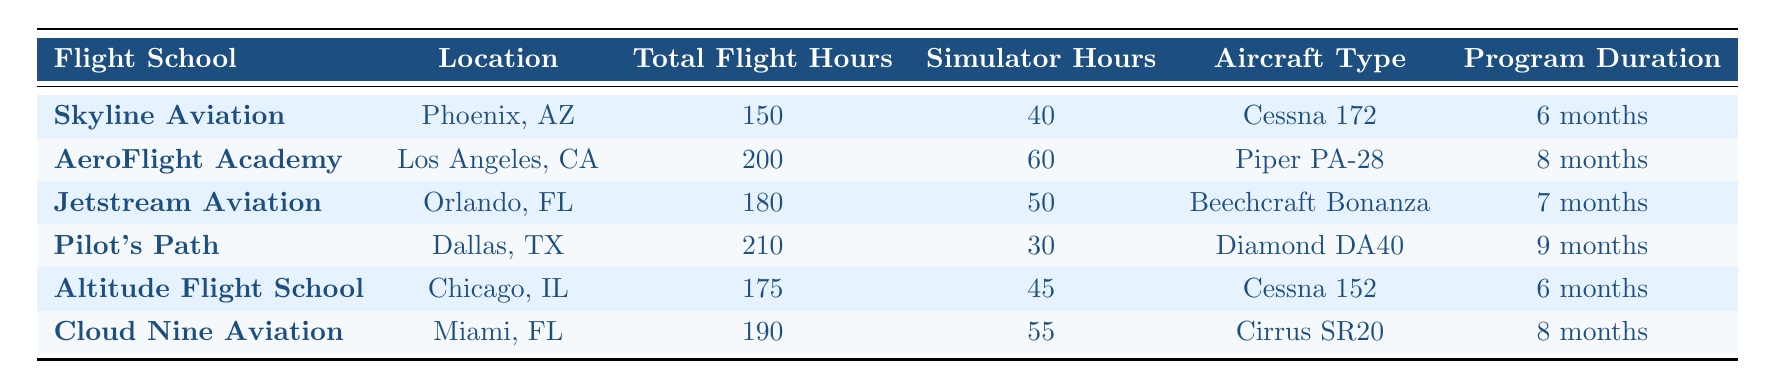What is the total flight hours for Pilot's Path? According to the table, Pilot's Path has a total of 210 flight hours listed in the "Total Flight Hours" column.
Answer: 210 Which flight school is located in Miami, FL? The table shows that Cloud Nine Aviation is the flight school located in Miami, FL, according to the "Location" column.
Answer: Cloud Nine Aviation What is the average total flight hours across all schools? To find the average, add all total flight hours: 150 + 200 + 180 + 210 + 175 + 190 = 1105. Then, divide by the number of schools (6), which gives 1105 / 6 = 184.17.
Answer: 184.17 True or False: Altitude Flight School has more simulator hours than Pilot's Path. Altitude Flight School has 45 simulator hours, while Pilot's Path has 30 simulator hours. Since 45 is greater than 30, the statement is true.
Answer: True What is the difference in total flight hours between AeroFlight Academy and Jetstream Aviation? AeroFlight Academy has 200 total flight hours, and Jetstream Aviation has 180 total flight hours. The difference is 200 - 180 = 20.
Answer: 20 Which flight school has the highest total flight hours? By comparing the total flight hours from all schools, Pilot's Path has the highest total at 210 hours, as it is the largest number in the "Total Flight Hours" column.
Answer: Pilot's Path How many more simulator hours does Cloud Nine Aviation have compared to Skyline Aviation? Cloud Nine Aviation has 55 simulator hours and Skyline Aviation has 40 simulator hours. The difference is 55 - 40 = 15.
Answer: 15 What is the total program duration for the flight schools located in CA? The flight schools in CA are AeroFlight Academy and they have a program duration of 8 months. So, the total for CA is 8 months.
Answer: 8 months Which aircraft type is used by Jetstream Aviation? According to the table, Jetstream Aviation uses the Beechcraft Bonanza, as noted in the "Aircraft Type" column.
Answer: Beechcraft Bonanza Which school has the shortest training program duration, and what is it? The schools with the shortest training program duration (6 months) are Skyline Aviation and Altitude Flight School.
Answer: Skyline Aviation and Altitude Flight School; 6 months 